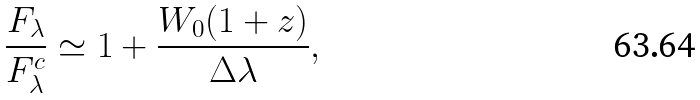Convert formula to latex. <formula><loc_0><loc_0><loc_500><loc_500>\frac { F _ { \lambda } } { F _ { \lambda } ^ { c } } \simeq 1 + \frac { W _ { 0 } ( 1 + z ) } { \Delta \lambda } ,</formula> 